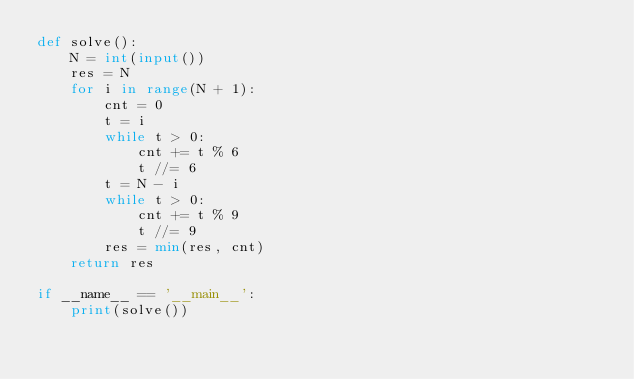<code> <loc_0><loc_0><loc_500><loc_500><_Python_>def solve():
    N = int(input())
    res = N
    for i in range(N + 1):
        cnt = 0
        t = i
        while t > 0:
            cnt += t % 6
            t //= 6
        t = N - i
        while t > 0:
            cnt += t % 9
            t //= 9
        res = min(res, cnt)
    return res

if __name__ == '__main__':
    print(solve())
</code> 